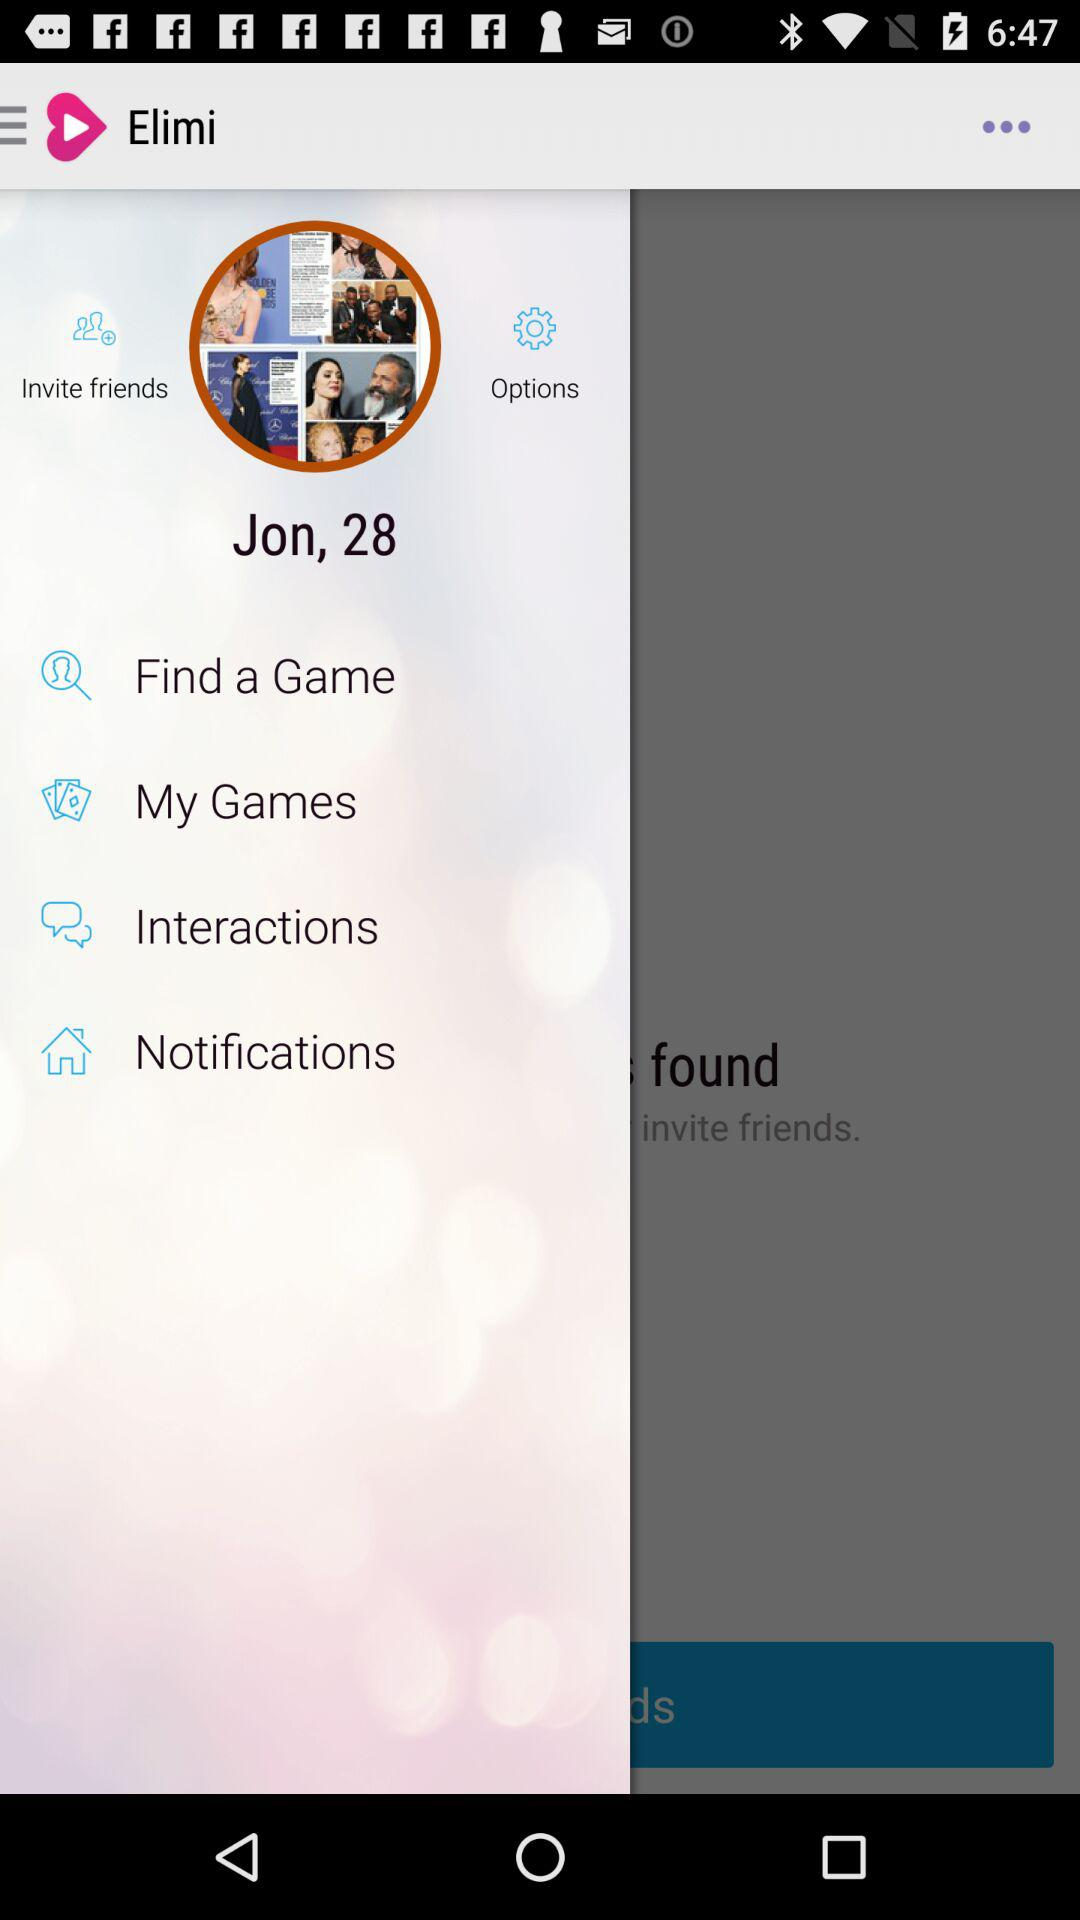What is the name of the user? The user name is Jon. 